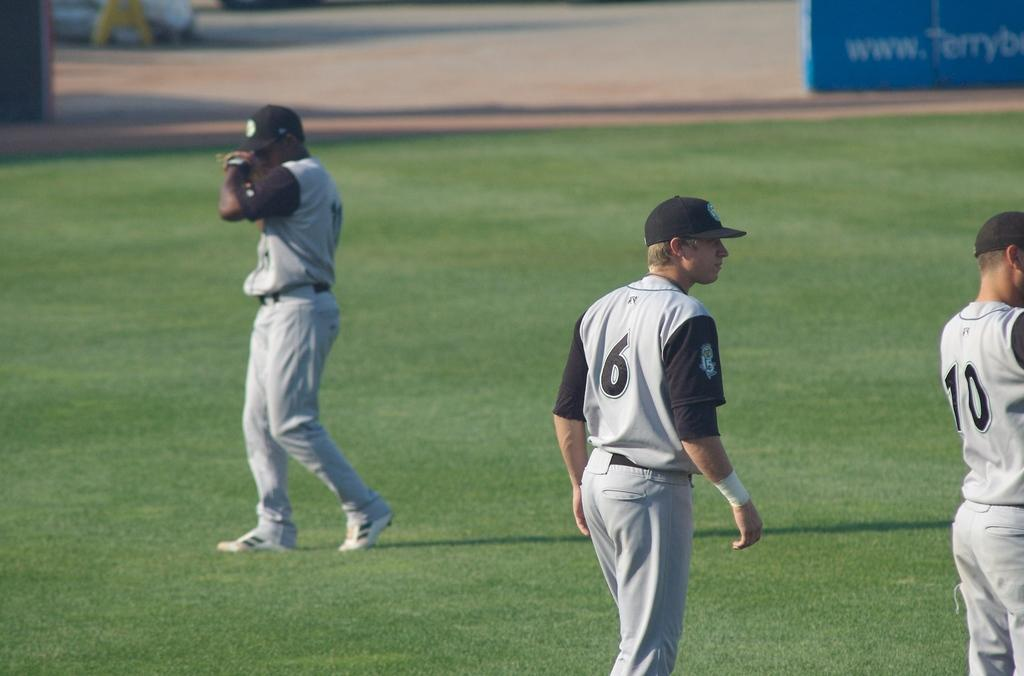Provide a one-sentence caption for the provided image. Baseball team at practice on a field with player 6 in the center. 